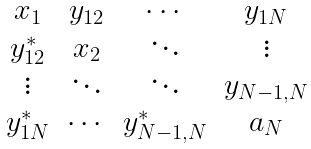Convert formula to latex. <formula><loc_0><loc_0><loc_500><loc_500>\begin{matrix} x _ { 1 } & y _ { 1 2 } & \cdots & y _ { 1 N } \\ y _ { 1 2 } ^ { * } & x _ { 2 } & \ddots & \vdots \\ \vdots & \ddots & \ddots & y _ { N - 1 , N } \\ y _ { 1 N } ^ { * } & \cdots & y _ { N - 1 , N } ^ { * } & a _ { N } \end{matrix}</formula> 